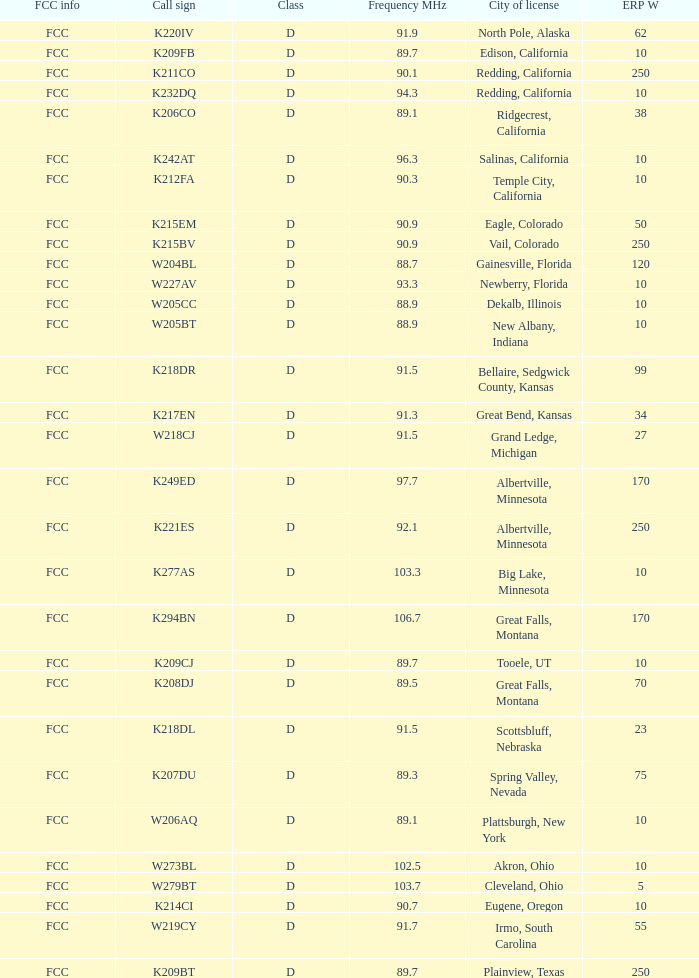What is the call sign of the translator with an ERP W greater than 38 and a city license from Great Falls, Montana? K294BN, K208DJ. 